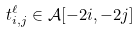Convert formula to latex. <formula><loc_0><loc_0><loc_500><loc_500>t _ { i , j } ^ { \ell } \in \mathcal { A } [ - 2 i , - 2 j ]</formula> 